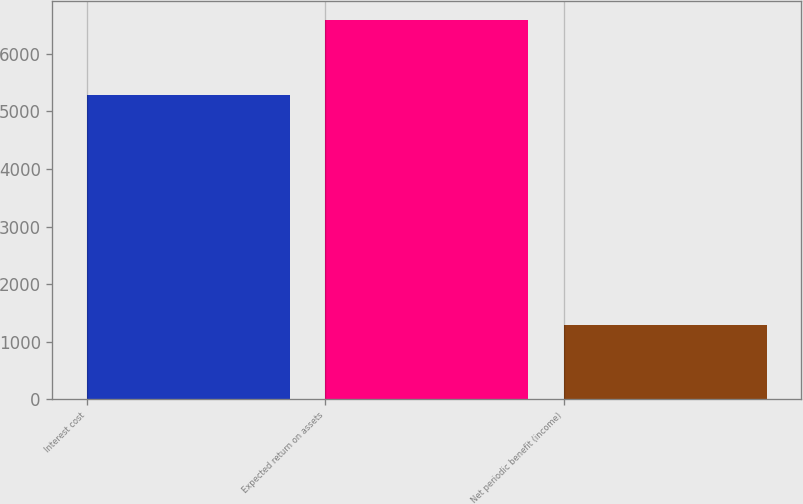Convert chart to OTSL. <chart><loc_0><loc_0><loc_500><loc_500><bar_chart><fcel>Interest cost<fcel>Expected return on assets<fcel>Net periodic benefit (income)<nl><fcel>5291<fcel>6584<fcel>1293<nl></chart> 